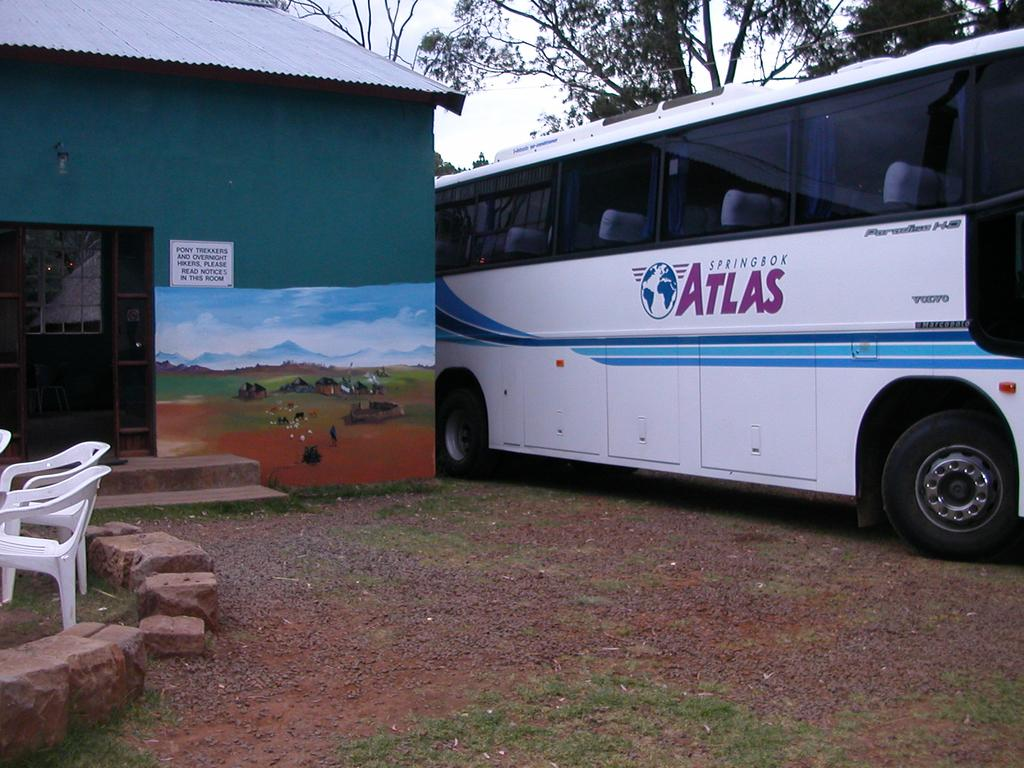What type of furniture is present in the image? There are chairs in the image. What other objects can be seen in the image? There are stones, a bus, and a house with a painting visible in the image. What is the background of the image? Trees are visible behind the bus, and the sky is visible in the image. What type of yam is being sold at the bus stop in the image? There is no yam present in the image; it features chairs, stones, a bus, a house with a painting, trees, and the sky. What is the rate of the bus in the image? The image does not provide information about the bus's rate; it only shows the bus and its surroundings. 